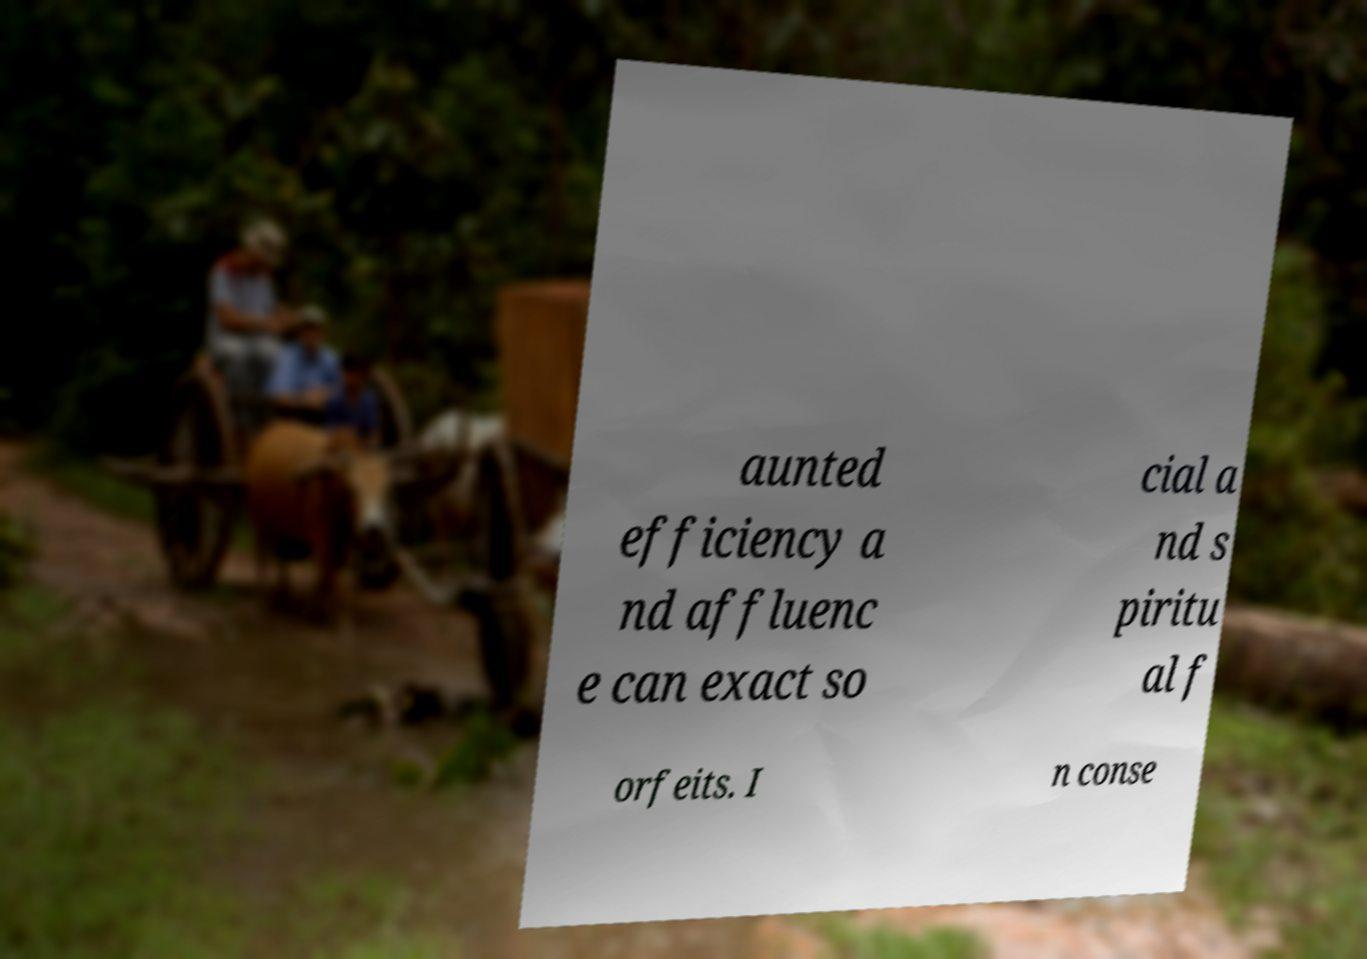Could you extract and type out the text from this image? aunted efficiency a nd affluenc e can exact so cial a nd s piritu al f orfeits. I n conse 